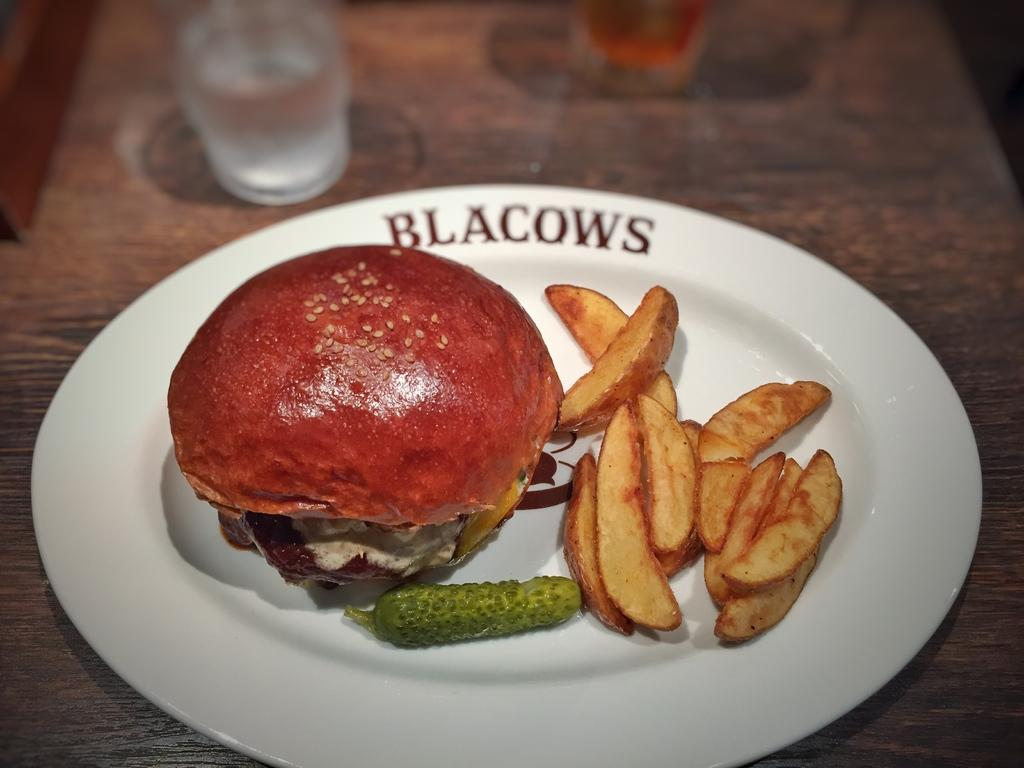What is present on the table in the image? There are eatable things on the table. How many glasses can be seen on the table? There are two glasses on the table. What type of apparatus is being used to measure the speed of the cars in the image? There are no cars or apparatus present in the image; it only features eatable things and glasses on a table. 